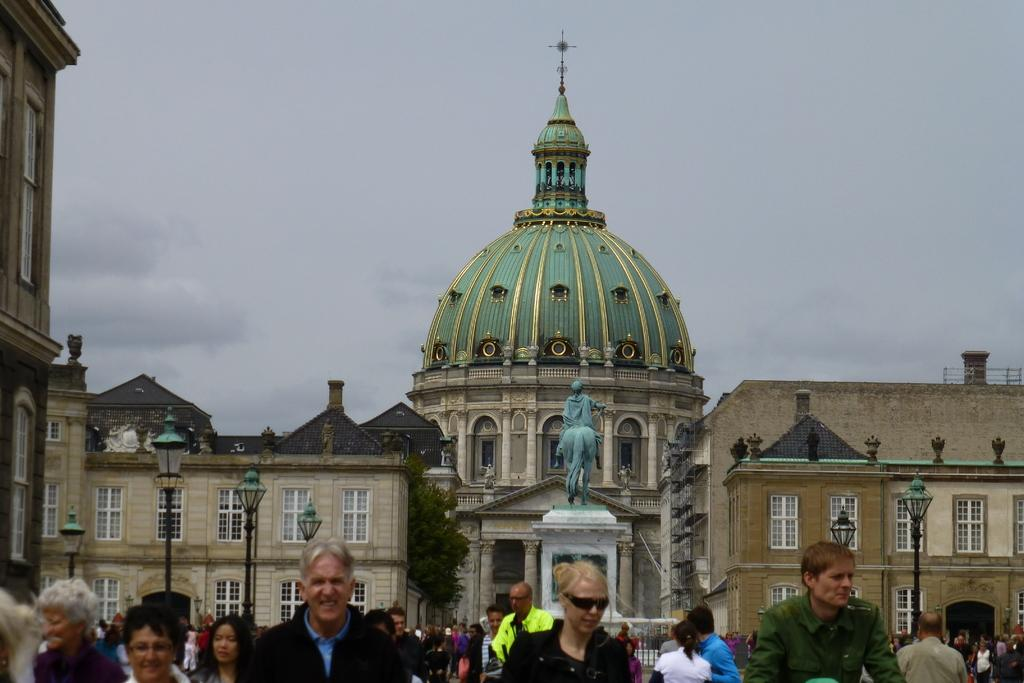What are the people in the image doing? The people in the image are walking on the road. What can be seen in the background of the image? There are buildings in the background. Can you describe the sculpture in the image? There is a sculpture attached to a pillar in the image. What type of structures are present to provide illumination? There are light poles in the image. What is visible above the buildings and light poles? The sky is visible in the image. Can you read the note that the boat is carrying in the image? There is no boat present in the image, so there is no note to read. 